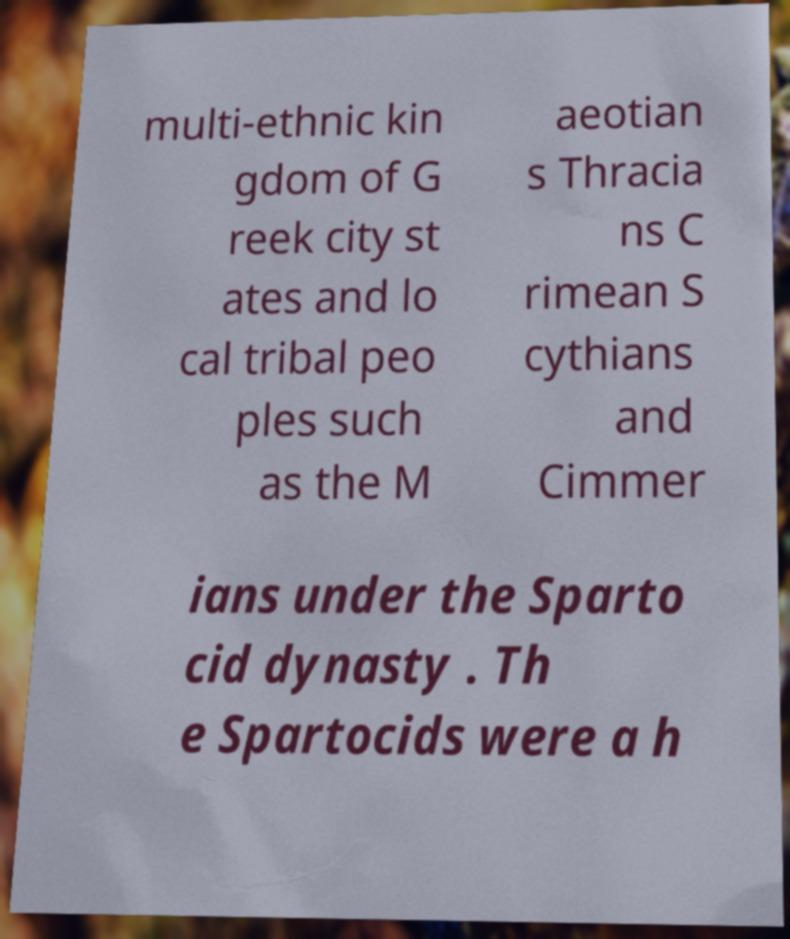There's text embedded in this image that I need extracted. Can you transcribe it verbatim? multi-ethnic kin gdom of G reek city st ates and lo cal tribal peo ples such as the M aeotian s Thracia ns C rimean S cythians and Cimmer ians under the Sparto cid dynasty . Th e Spartocids were a h 